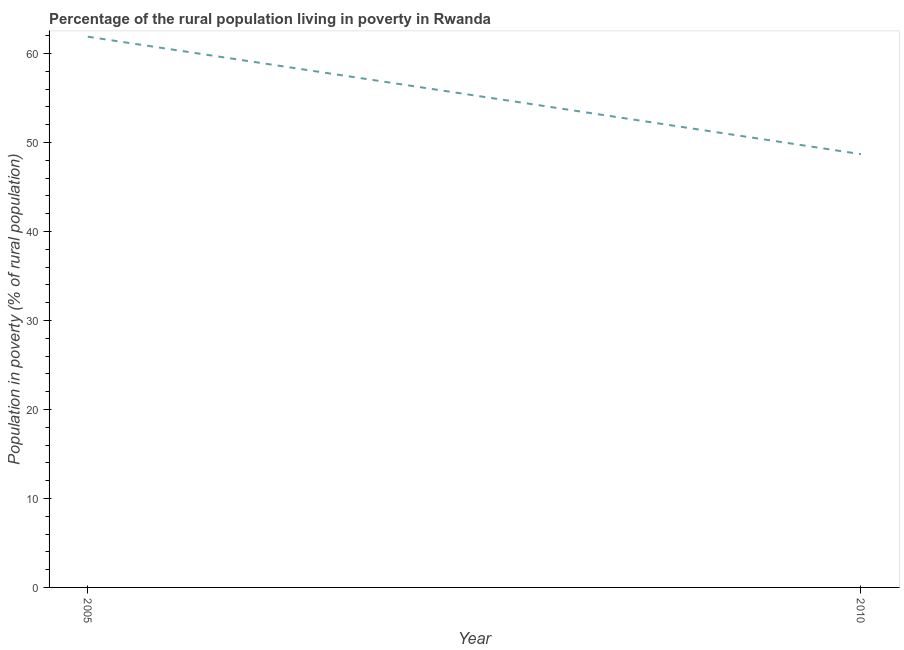What is the percentage of rural population living below poverty line in 2010?
Your response must be concise. 48.7. Across all years, what is the maximum percentage of rural population living below poverty line?
Keep it short and to the point. 61.9. Across all years, what is the minimum percentage of rural population living below poverty line?
Offer a terse response. 48.7. In which year was the percentage of rural population living below poverty line minimum?
Offer a terse response. 2010. What is the sum of the percentage of rural population living below poverty line?
Provide a short and direct response. 110.6. What is the difference between the percentage of rural population living below poverty line in 2005 and 2010?
Provide a short and direct response. 13.2. What is the average percentage of rural population living below poverty line per year?
Your answer should be compact. 55.3. What is the median percentage of rural population living below poverty line?
Offer a very short reply. 55.3. What is the ratio of the percentage of rural population living below poverty line in 2005 to that in 2010?
Ensure brevity in your answer.  1.27. In how many years, is the percentage of rural population living below poverty line greater than the average percentage of rural population living below poverty line taken over all years?
Give a very brief answer. 1. Does the percentage of rural population living below poverty line monotonically increase over the years?
Your response must be concise. No. How many years are there in the graph?
Offer a terse response. 2. Are the values on the major ticks of Y-axis written in scientific E-notation?
Your answer should be compact. No. What is the title of the graph?
Make the answer very short. Percentage of the rural population living in poverty in Rwanda. What is the label or title of the Y-axis?
Your response must be concise. Population in poverty (% of rural population). What is the Population in poverty (% of rural population) of 2005?
Make the answer very short. 61.9. What is the Population in poverty (% of rural population) of 2010?
Provide a short and direct response. 48.7. What is the ratio of the Population in poverty (% of rural population) in 2005 to that in 2010?
Your answer should be very brief. 1.27. 